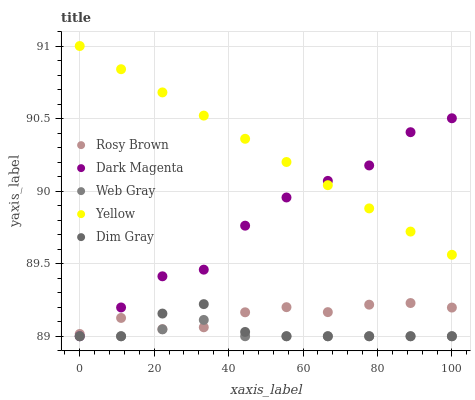Does Web Gray have the minimum area under the curve?
Answer yes or no. Yes. Does Yellow have the maximum area under the curve?
Answer yes or no. Yes. Does Rosy Brown have the minimum area under the curve?
Answer yes or no. No. Does Rosy Brown have the maximum area under the curve?
Answer yes or no. No. Is Yellow the smoothest?
Answer yes or no. Yes. Is Dark Magenta the roughest?
Answer yes or no. Yes. Is Rosy Brown the smoothest?
Answer yes or no. No. Is Rosy Brown the roughest?
Answer yes or no. No. Does Dim Gray have the lowest value?
Answer yes or no. Yes. Does Rosy Brown have the lowest value?
Answer yes or no. No. Does Yellow have the highest value?
Answer yes or no. Yes. Does Rosy Brown have the highest value?
Answer yes or no. No. Is Dim Gray less than Yellow?
Answer yes or no. Yes. Is Yellow greater than Dim Gray?
Answer yes or no. Yes. Does Dark Magenta intersect Yellow?
Answer yes or no. Yes. Is Dark Magenta less than Yellow?
Answer yes or no. No. Is Dark Magenta greater than Yellow?
Answer yes or no. No. Does Dim Gray intersect Yellow?
Answer yes or no. No. 